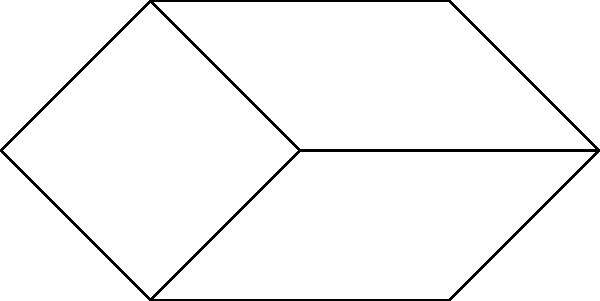As a disc golf tournament organizer, you need to group players efficiently for a round-robin style event. The graph represents player compatibility, where connected players can be grouped together. What is the minimum number of groups needed to ensure all players are grouped with only compatible players? To solve this problem, we need to find the chromatic number of the graph, which represents the minimum number of colors (groups) needed to color all vertices (players) such that no adjacent vertices have the same color.

Step 1: Analyze the graph structure
The graph has 7 vertices (players) with various connections.

Step 2: Apply the greedy coloring algorithm
1. Start with P1: Assign color 1
2. P2: Connected to P1, assign color 2
3. P3: Connected to P2, assign color 1
4. P4: Connected to P1, P2, and P3, assign color 3
5. P5: Connected to P2, assign color 1
6. P6: Connected to P3 and P5, assign color 2
7. P7: Connected to P4, assign color 1

Step 3: Count the number of colors used
The greedy algorithm uses 3 colors, which means we need a minimum of 3 groups.

Step 4: Verify that no adjacent vertices have the same color
Check all connections to ensure no connected players are in the same group.

Step 5: Confirm optimality
While the greedy algorithm doesn't always produce the optimal solution, in this case, 3 is indeed the minimum number of groups needed, as there is a triangle formed by P1, P2, and P4, which requires at least 3 colors.
Answer: 3 groups 